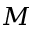Convert formula to latex. <formula><loc_0><loc_0><loc_500><loc_500>M</formula> 